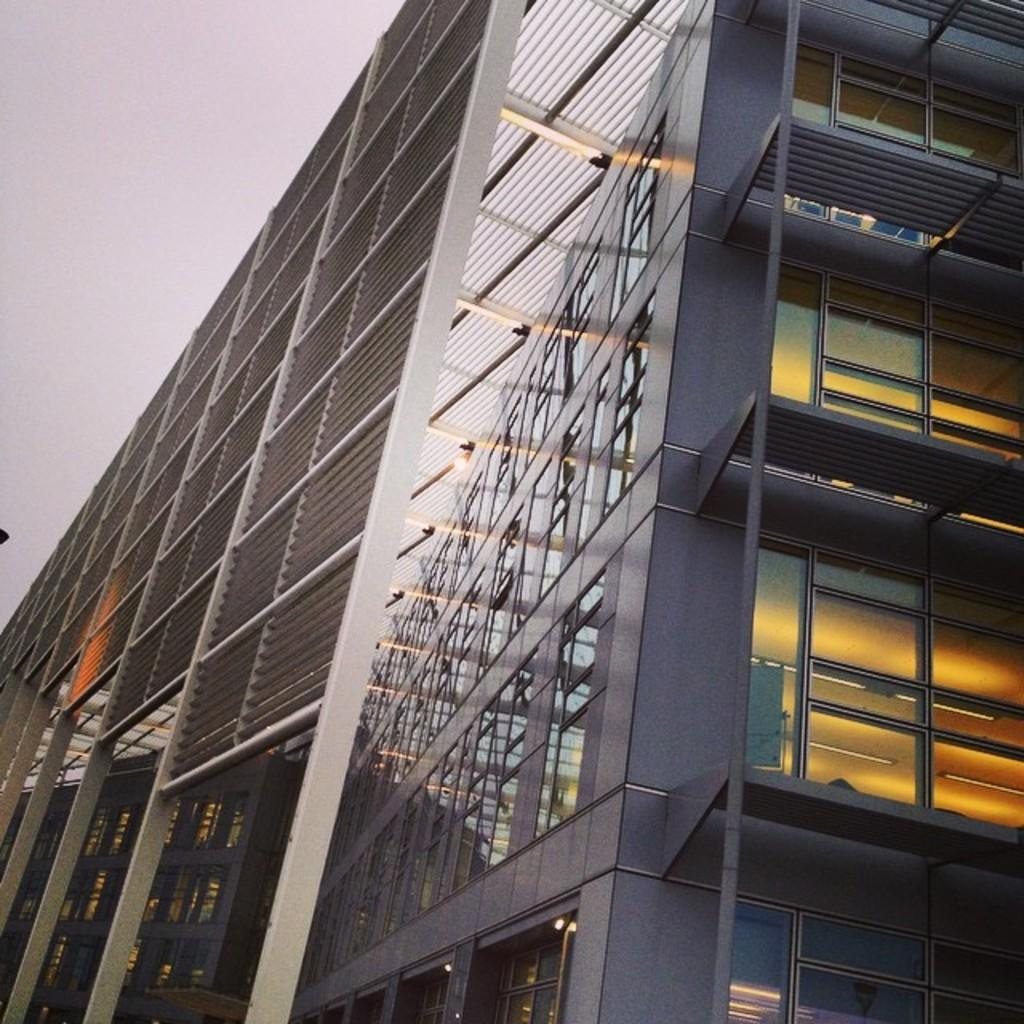What structure is present in the image? There is a building in the image. What can be seen on the right side of the image? There are light beams visible on the right side of the image. What feature allows natural light to enter the building? There are windows visible in the image. What is visible in the top left corner of the image? The sky is visible in the top left corner of the image. What type of bedding is used to cover the bed in the image? There is no bed or bedding present in the image; it features a building with light beams, windows, and a visible sky. 